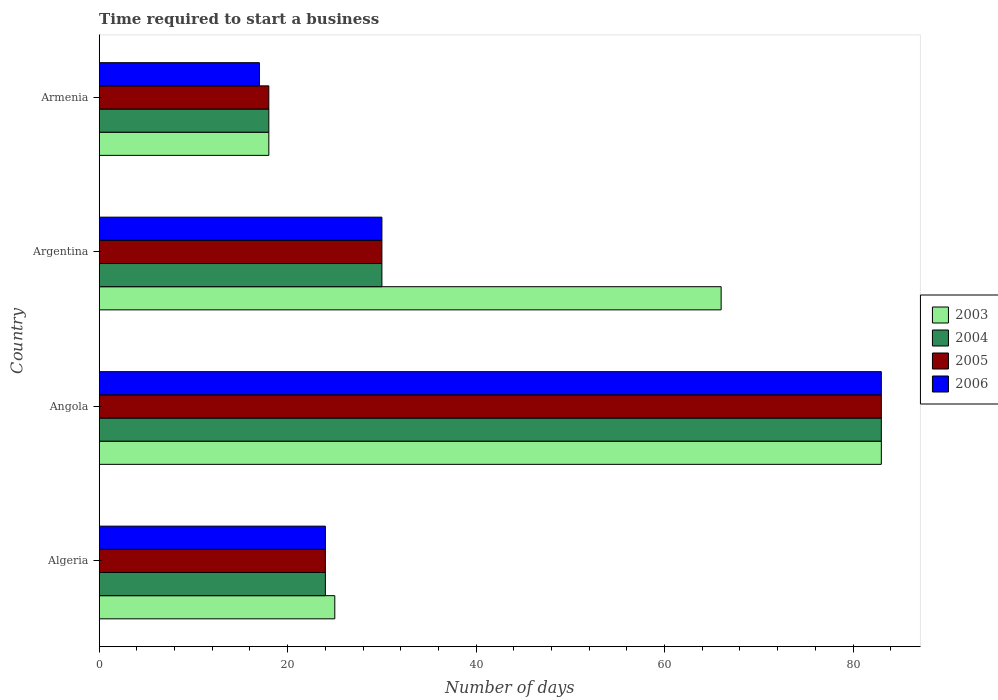How many different coloured bars are there?
Provide a succinct answer. 4. How many groups of bars are there?
Give a very brief answer. 4. Are the number of bars on each tick of the Y-axis equal?
Offer a very short reply. Yes. What is the label of the 1st group of bars from the top?
Give a very brief answer. Armenia. In which country was the number of days required to start a business in 2006 maximum?
Make the answer very short. Angola. In which country was the number of days required to start a business in 2005 minimum?
Your answer should be very brief. Armenia. What is the total number of days required to start a business in 2006 in the graph?
Keep it short and to the point. 154. What is the difference between the number of days required to start a business in 2006 in Algeria and that in Armenia?
Offer a very short reply. 7. What is the average number of days required to start a business in 2004 per country?
Offer a terse response. 38.75. What is the difference between the number of days required to start a business in 2003 and number of days required to start a business in 2005 in Armenia?
Your answer should be very brief. 0. What is the ratio of the number of days required to start a business in 2003 in Argentina to that in Armenia?
Make the answer very short. 3.67. Is the difference between the number of days required to start a business in 2003 in Algeria and Armenia greater than the difference between the number of days required to start a business in 2005 in Algeria and Armenia?
Give a very brief answer. Yes. What is the difference between the highest and the lowest number of days required to start a business in 2004?
Offer a terse response. 65. In how many countries, is the number of days required to start a business in 2003 greater than the average number of days required to start a business in 2003 taken over all countries?
Give a very brief answer. 2. Is the sum of the number of days required to start a business in 2005 in Argentina and Armenia greater than the maximum number of days required to start a business in 2004 across all countries?
Make the answer very short. No. What does the 4th bar from the top in Argentina represents?
Provide a short and direct response. 2003. What does the 1st bar from the bottom in Angola represents?
Provide a succinct answer. 2003. What is the difference between two consecutive major ticks on the X-axis?
Your answer should be very brief. 20. Are the values on the major ticks of X-axis written in scientific E-notation?
Give a very brief answer. No. Does the graph contain any zero values?
Give a very brief answer. No. Does the graph contain grids?
Provide a succinct answer. No. Where does the legend appear in the graph?
Your answer should be very brief. Center right. How many legend labels are there?
Offer a very short reply. 4. What is the title of the graph?
Offer a very short reply. Time required to start a business. What is the label or title of the X-axis?
Your answer should be very brief. Number of days. What is the label or title of the Y-axis?
Offer a terse response. Country. What is the Number of days in 2003 in Algeria?
Keep it short and to the point. 25. What is the Number of days in 2006 in Algeria?
Your response must be concise. 24. What is the Number of days of 2004 in Angola?
Keep it short and to the point. 83. What is the Number of days of 2006 in Argentina?
Your response must be concise. 30. What is the Number of days of 2003 in Armenia?
Provide a short and direct response. 18. What is the Number of days of 2006 in Armenia?
Keep it short and to the point. 17. Across all countries, what is the maximum Number of days in 2003?
Offer a terse response. 83. Across all countries, what is the minimum Number of days of 2006?
Offer a terse response. 17. What is the total Number of days in 2003 in the graph?
Offer a terse response. 192. What is the total Number of days in 2004 in the graph?
Make the answer very short. 155. What is the total Number of days in 2005 in the graph?
Your answer should be compact. 155. What is the total Number of days of 2006 in the graph?
Your answer should be compact. 154. What is the difference between the Number of days of 2003 in Algeria and that in Angola?
Give a very brief answer. -58. What is the difference between the Number of days in 2004 in Algeria and that in Angola?
Your response must be concise. -59. What is the difference between the Number of days in 2005 in Algeria and that in Angola?
Your response must be concise. -59. What is the difference between the Number of days of 2006 in Algeria and that in Angola?
Keep it short and to the point. -59. What is the difference between the Number of days of 2003 in Algeria and that in Argentina?
Ensure brevity in your answer.  -41. What is the difference between the Number of days in 2004 in Algeria and that in Argentina?
Make the answer very short. -6. What is the difference between the Number of days of 2003 in Algeria and that in Armenia?
Ensure brevity in your answer.  7. What is the difference between the Number of days in 2004 in Angola and that in Argentina?
Make the answer very short. 53. What is the difference between the Number of days of 2005 in Angola and that in Argentina?
Offer a terse response. 53. What is the difference between the Number of days of 2006 in Angola and that in Argentina?
Offer a terse response. 53. What is the difference between the Number of days in 2003 in Angola and that in Armenia?
Provide a succinct answer. 65. What is the difference between the Number of days in 2004 in Angola and that in Armenia?
Give a very brief answer. 65. What is the difference between the Number of days of 2004 in Argentina and that in Armenia?
Offer a terse response. 12. What is the difference between the Number of days in 2003 in Algeria and the Number of days in 2004 in Angola?
Provide a succinct answer. -58. What is the difference between the Number of days of 2003 in Algeria and the Number of days of 2005 in Angola?
Give a very brief answer. -58. What is the difference between the Number of days in 2003 in Algeria and the Number of days in 2006 in Angola?
Offer a very short reply. -58. What is the difference between the Number of days in 2004 in Algeria and the Number of days in 2005 in Angola?
Give a very brief answer. -59. What is the difference between the Number of days of 2004 in Algeria and the Number of days of 2006 in Angola?
Your answer should be compact. -59. What is the difference between the Number of days in 2005 in Algeria and the Number of days in 2006 in Angola?
Keep it short and to the point. -59. What is the difference between the Number of days of 2003 in Algeria and the Number of days of 2004 in Argentina?
Your answer should be compact. -5. What is the difference between the Number of days of 2004 in Algeria and the Number of days of 2005 in Argentina?
Your answer should be compact. -6. What is the difference between the Number of days of 2005 in Algeria and the Number of days of 2006 in Argentina?
Keep it short and to the point. -6. What is the difference between the Number of days in 2003 in Algeria and the Number of days in 2005 in Armenia?
Keep it short and to the point. 7. What is the difference between the Number of days in 2004 in Algeria and the Number of days in 2005 in Armenia?
Your answer should be very brief. 6. What is the difference between the Number of days of 2004 in Algeria and the Number of days of 2006 in Armenia?
Give a very brief answer. 7. What is the difference between the Number of days of 2003 in Angola and the Number of days of 2004 in Argentina?
Give a very brief answer. 53. What is the difference between the Number of days in 2004 in Angola and the Number of days in 2005 in Argentina?
Make the answer very short. 53. What is the difference between the Number of days of 2004 in Angola and the Number of days of 2006 in Argentina?
Ensure brevity in your answer.  53. What is the difference between the Number of days of 2005 in Angola and the Number of days of 2006 in Argentina?
Make the answer very short. 53. What is the difference between the Number of days of 2003 in Angola and the Number of days of 2004 in Armenia?
Provide a short and direct response. 65. What is the difference between the Number of days of 2003 in Angola and the Number of days of 2005 in Armenia?
Give a very brief answer. 65. What is the difference between the Number of days in 2003 in Angola and the Number of days in 2006 in Armenia?
Your response must be concise. 66. What is the difference between the Number of days of 2004 in Angola and the Number of days of 2005 in Armenia?
Your answer should be very brief. 65. What is the difference between the Number of days in 2005 in Angola and the Number of days in 2006 in Armenia?
Ensure brevity in your answer.  66. What is the difference between the Number of days of 2003 in Argentina and the Number of days of 2005 in Armenia?
Provide a succinct answer. 48. What is the difference between the Number of days of 2004 in Argentina and the Number of days of 2005 in Armenia?
Offer a terse response. 12. What is the difference between the Number of days in 2004 in Argentina and the Number of days in 2006 in Armenia?
Give a very brief answer. 13. What is the difference between the Number of days of 2005 in Argentina and the Number of days of 2006 in Armenia?
Provide a succinct answer. 13. What is the average Number of days in 2004 per country?
Your response must be concise. 38.75. What is the average Number of days of 2005 per country?
Make the answer very short. 38.75. What is the average Number of days in 2006 per country?
Provide a short and direct response. 38.5. What is the difference between the Number of days of 2003 and Number of days of 2004 in Algeria?
Provide a short and direct response. 1. What is the difference between the Number of days in 2003 and Number of days in 2005 in Algeria?
Provide a succinct answer. 1. What is the difference between the Number of days of 2003 and Number of days of 2006 in Algeria?
Provide a succinct answer. 1. What is the difference between the Number of days in 2004 and Number of days in 2006 in Algeria?
Give a very brief answer. 0. What is the difference between the Number of days in 2003 and Number of days in 2004 in Angola?
Your answer should be compact. 0. What is the difference between the Number of days in 2003 and Number of days in 2005 in Angola?
Your answer should be very brief. 0. What is the difference between the Number of days in 2003 and Number of days in 2006 in Angola?
Make the answer very short. 0. What is the difference between the Number of days in 2005 and Number of days in 2006 in Angola?
Make the answer very short. 0. What is the difference between the Number of days in 2003 and Number of days in 2004 in Argentina?
Ensure brevity in your answer.  36. What is the difference between the Number of days in 2003 and Number of days in 2006 in Armenia?
Your response must be concise. 1. What is the difference between the Number of days of 2004 and Number of days of 2005 in Armenia?
Give a very brief answer. 0. What is the ratio of the Number of days in 2003 in Algeria to that in Angola?
Keep it short and to the point. 0.3. What is the ratio of the Number of days in 2004 in Algeria to that in Angola?
Offer a very short reply. 0.29. What is the ratio of the Number of days of 2005 in Algeria to that in Angola?
Offer a terse response. 0.29. What is the ratio of the Number of days in 2006 in Algeria to that in Angola?
Your answer should be very brief. 0.29. What is the ratio of the Number of days in 2003 in Algeria to that in Argentina?
Provide a succinct answer. 0.38. What is the ratio of the Number of days of 2005 in Algeria to that in Argentina?
Provide a short and direct response. 0.8. What is the ratio of the Number of days in 2006 in Algeria to that in Argentina?
Give a very brief answer. 0.8. What is the ratio of the Number of days of 2003 in Algeria to that in Armenia?
Make the answer very short. 1.39. What is the ratio of the Number of days in 2004 in Algeria to that in Armenia?
Give a very brief answer. 1.33. What is the ratio of the Number of days in 2005 in Algeria to that in Armenia?
Your answer should be compact. 1.33. What is the ratio of the Number of days of 2006 in Algeria to that in Armenia?
Give a very brief answer. 1.41. What is the ratio of the Number of days in 2003 in Angola to that in Argentina?
Offer a very short reply. 1.26. What is the ratio of the Number of days of 2004 in Angola to that in Argentina?
Give a very brief answer. 2.77. What is the ratio of the Number of days of 2005 in Angola to that in Argentina?
Offer a very short reply. 2.77. What is the ratio of the Number of days of 2006 in Angola to that in Argentina?
Keep it short and to the point. 2.77. What is the ratio of the Number of days in 2003 in Angola to that in Armenia?
Provide a succinct answer. 4.61. What is the ratio of the Number of days in 2004 in Angola to that in Armenia?
Provide a succinct answer. 4.61. What is the ratio of the Number of days of 2005 in Angola to that in Armenia?
Your answer should be very brief. 4.61. What is the ratio of the Number of days in 2006 in Angola to that in Armenia?
Provide a succinct answer. 4.88. What is the ratio of the Number of days in 2003 in Argentina to that in Armenia?
Provide a short and direct response. 3.67. What is the ratio of the Number of days in 2004 in Argentina to that in Armenia?
Your answer should be compact. 1.67. What is the ratio of the Number of days in 2006 in Argentina to that in Armenia?
Give a very brief answer. 1.76. What is the difference between the highest and the second highest Number of days of 2006?
Keep it short and to the point. 53. What is the difference between the highest and the lowest Number of days in 2004?
Offer a very short reply. 65. What is the difference between the highest and the lowest Number of days of 2005?
Provide a succinct answer. 65. What is the difference between the highest and the lowest Number of days of 2006?
Give a very brief answer. 66. 